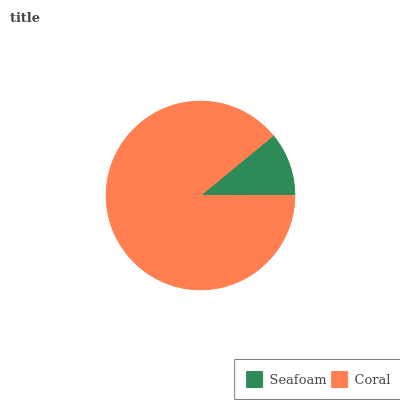Is Seafoam the minimum?
Answer yes or no. Yes. Is Coral the maximum?
Answer yes or no. Yes. Is Coral the minimum?
Answer yes or no. No. Is Coral greater than Seafoam?
Answer yes or no. Yes. Is Seafoam less than Coral?
Answer yes or no. Yes. Is Seafoam greater than Coral?
Answer yes or no. No. Is Coral less than Seafoam?
Answer yes or no. No. Is Coral the high median?
Answer yes or no. Yes. Is Seafoam the low median?
Answer yes or no. Yes. Is Seafoam the high median?
Answer yes or no. No. Is Coral the low median?
Answer yes or no. No. 